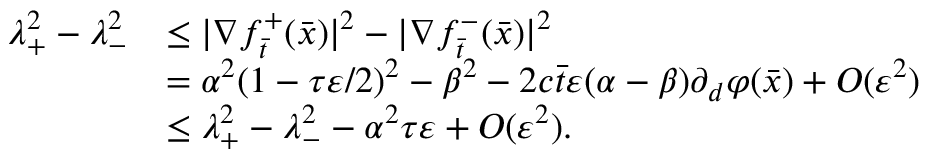<formula> <loc_0><loc_0><loc_500><loc_500>\begin{array} { r l } { \lambda _ { + } ^ { 2 } - \lambda _ { - } ^ { 2 } } & { \leq | \nabla f _ { \bar { t } } ^ { + } ( \bar { x } ) | ^ { 2 } - | \nabla f _ { \bar { t } } ^ { - } ( \bar { x } ) | ^ { 2 } } \\ & { = \alpha ^ { 2 } ( 1 - \tau \varepsilon / 2 ) ^ { 2 } - \beta ^ { 2 } - 2 c \bar { t } \varepsilon ( \alpha - \beta ) \partial _ { d } \varphi ( \bar { x } ) + O ( \varepsilon ^ { 2 } ) } \\ & { \leq \lambda _ { + } ^ { 2 } - \lambda _ { - } ^ { 2 } - \alpha ^ { 2 } \tau \varepsilon + O ( \varepsilon ^ { 2 } ) . } \end{array}</formula> 